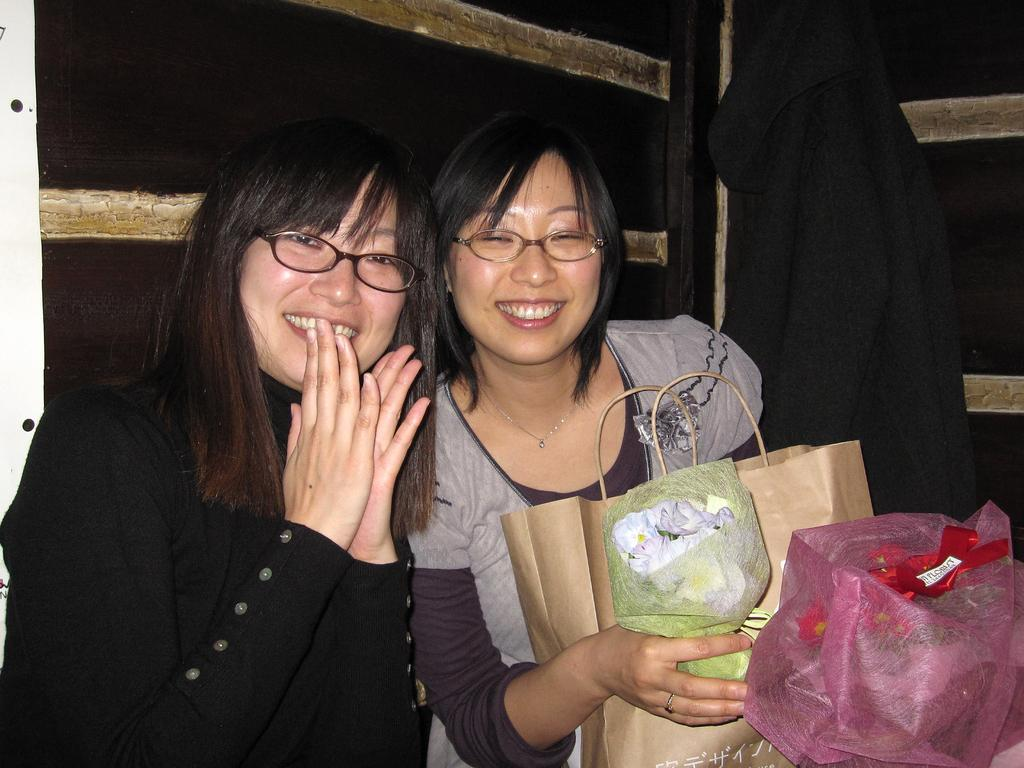Who is present in the image? There are women in the image. What are the women doing in the image? The women are sitting and smiling. What is one of the women holding in her hands? One of the women is holding paper bags in her hands. What type of ice can be seen melting on the boat in the image? There is no ice or boat present in the image; it features women sitting and smiling. 